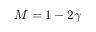Convert formula to latex. <formula><loc_0><loc_0><loc_500><loc_500>M = 1 - 2 \gamma</formula> 